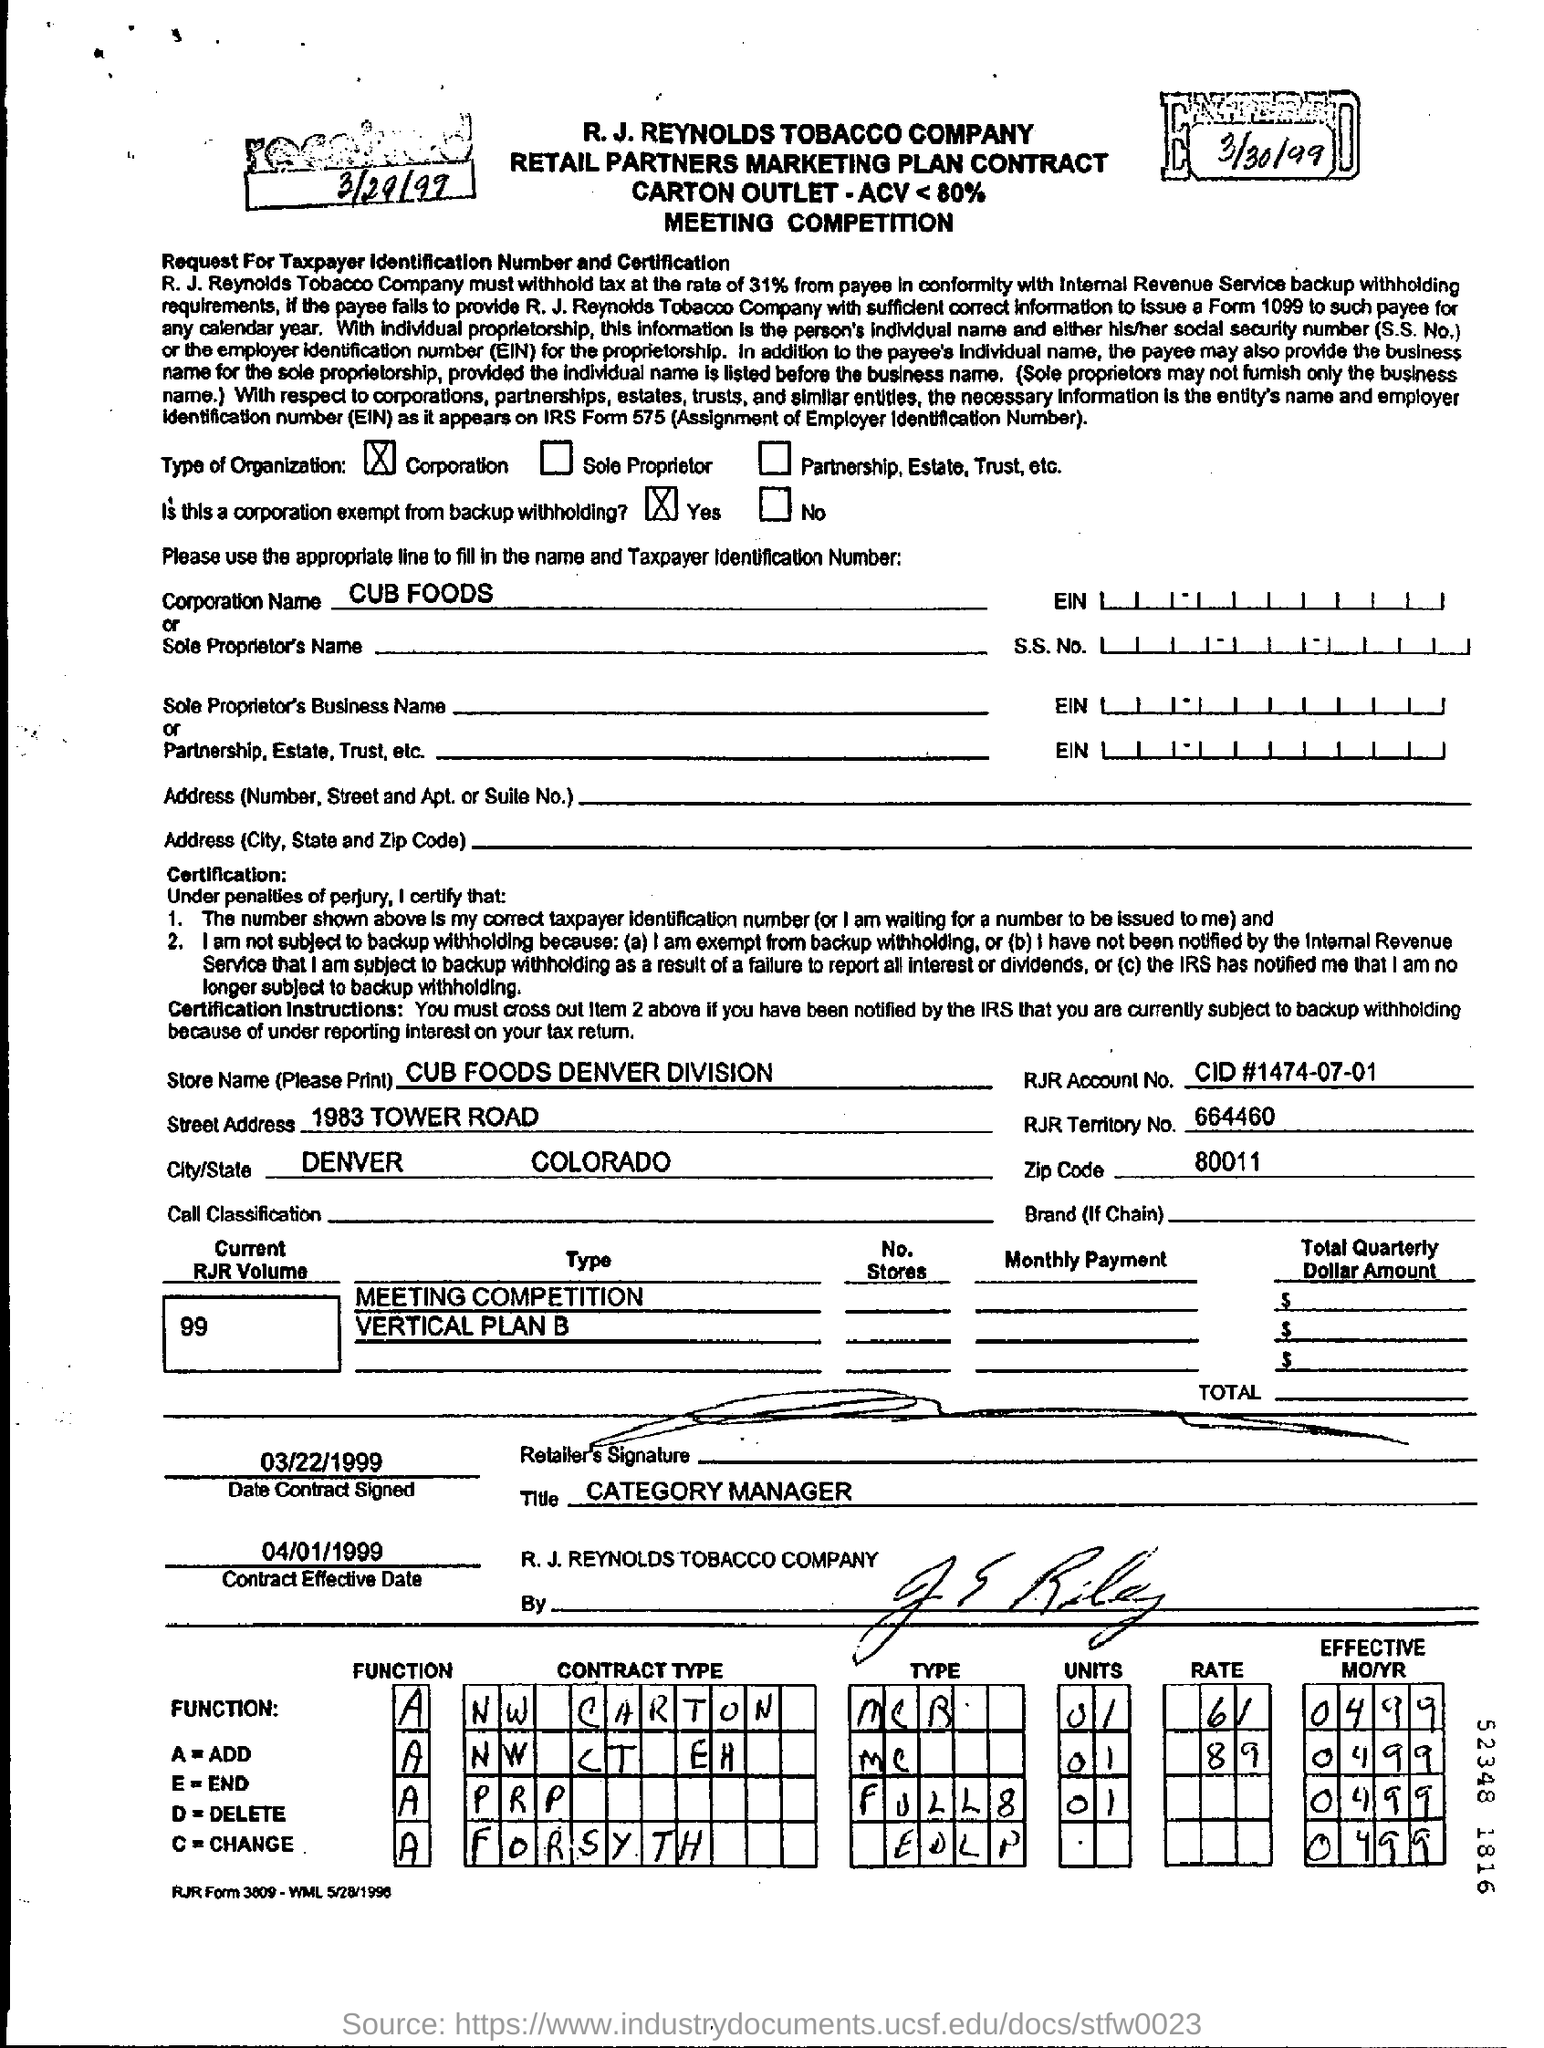What is the date mentioned at the top left corner of the document?
Provide a short and direct response. 3/29/99. Is this a corporation exempt from backup withholding?
Your answer should be very brief. Yes. What is the name of the corporation?
Your response must be concise. CUB FOODS. What does A mean according to the FUNCTION?
Provide a succinct answer. Add. 